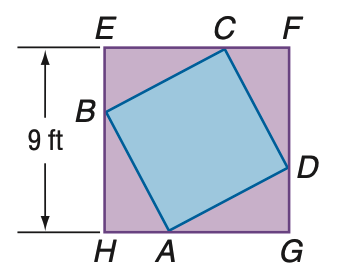Answer the mathemtical geometry problem and directly provide the correct option letter.
Question: In the figure, the vertices of quadrilateral A B C D intersect square E F G H and divide its sides into segments with measure that have a ratio of 1:2. Find the ratio between the areas of A B C D and E F G H.
Choices: A: 1:4 B: 1:2 C: 5:9 D: 1: \sqrt 2 C 